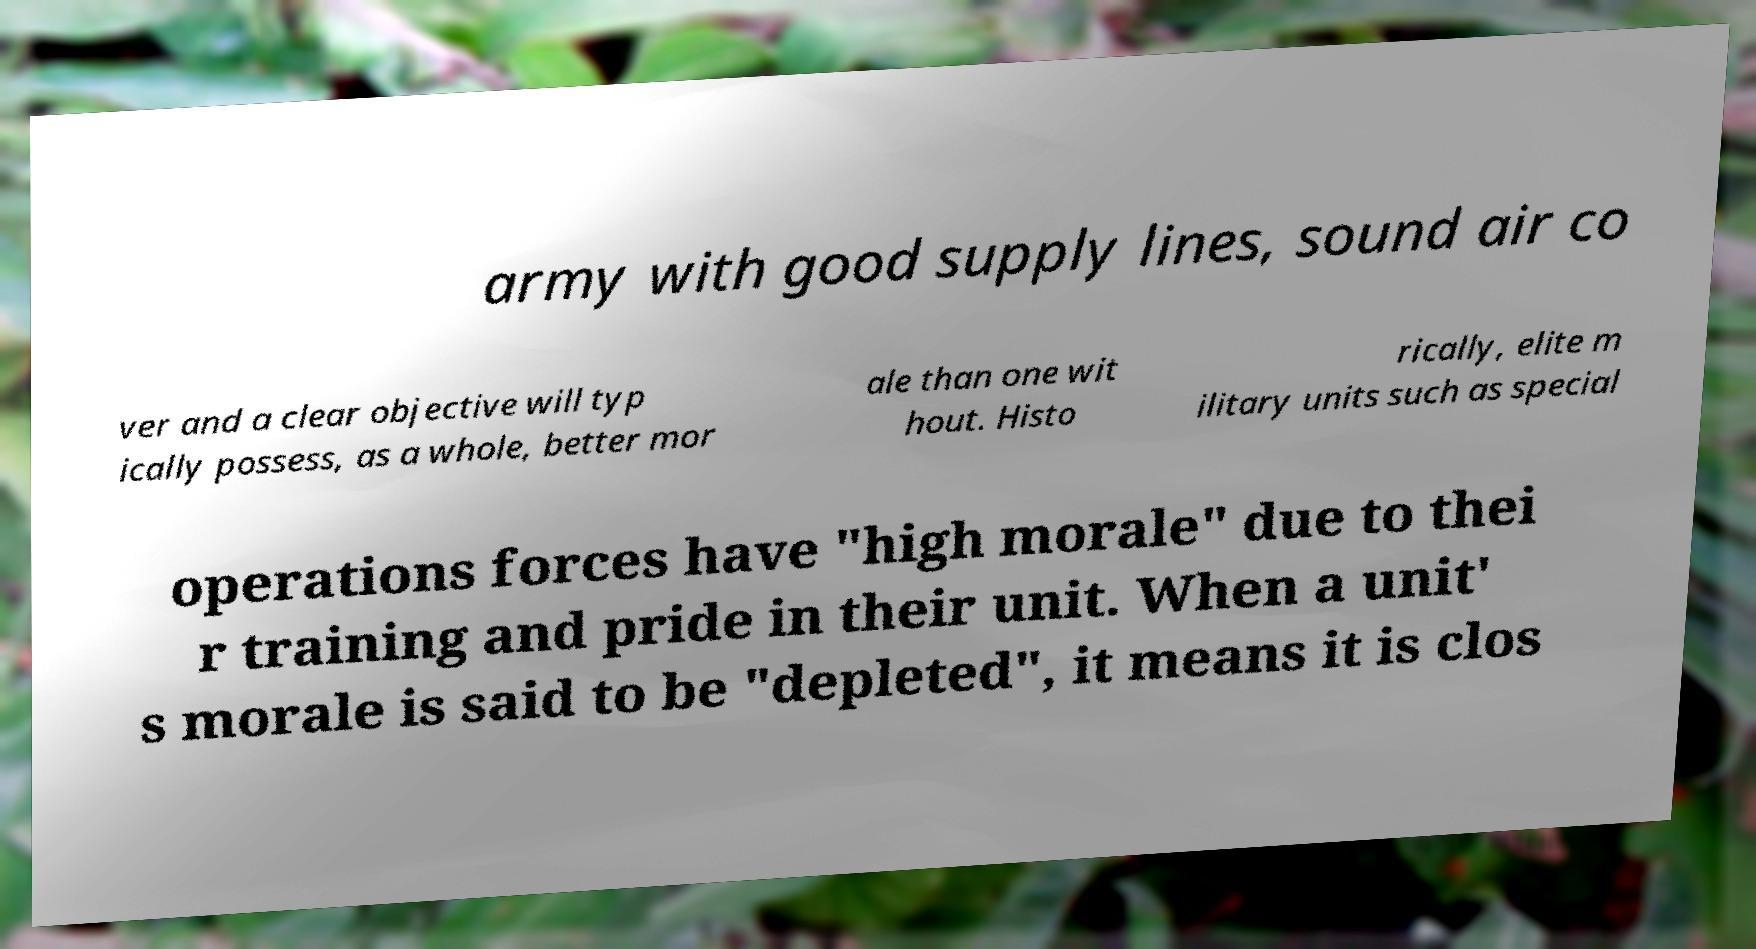Could you extract and type out the text from this image? army with good supply lines, sound air co ver and a clear objective will typ ically possess, as a whole, better mor ale than one wit hout. Histo rically, elite m ilitary units such as special operations forces have "high morale" due to thei r training and pride in their unit. When a unit' s morale is said to be "depleted", it means it is clos 